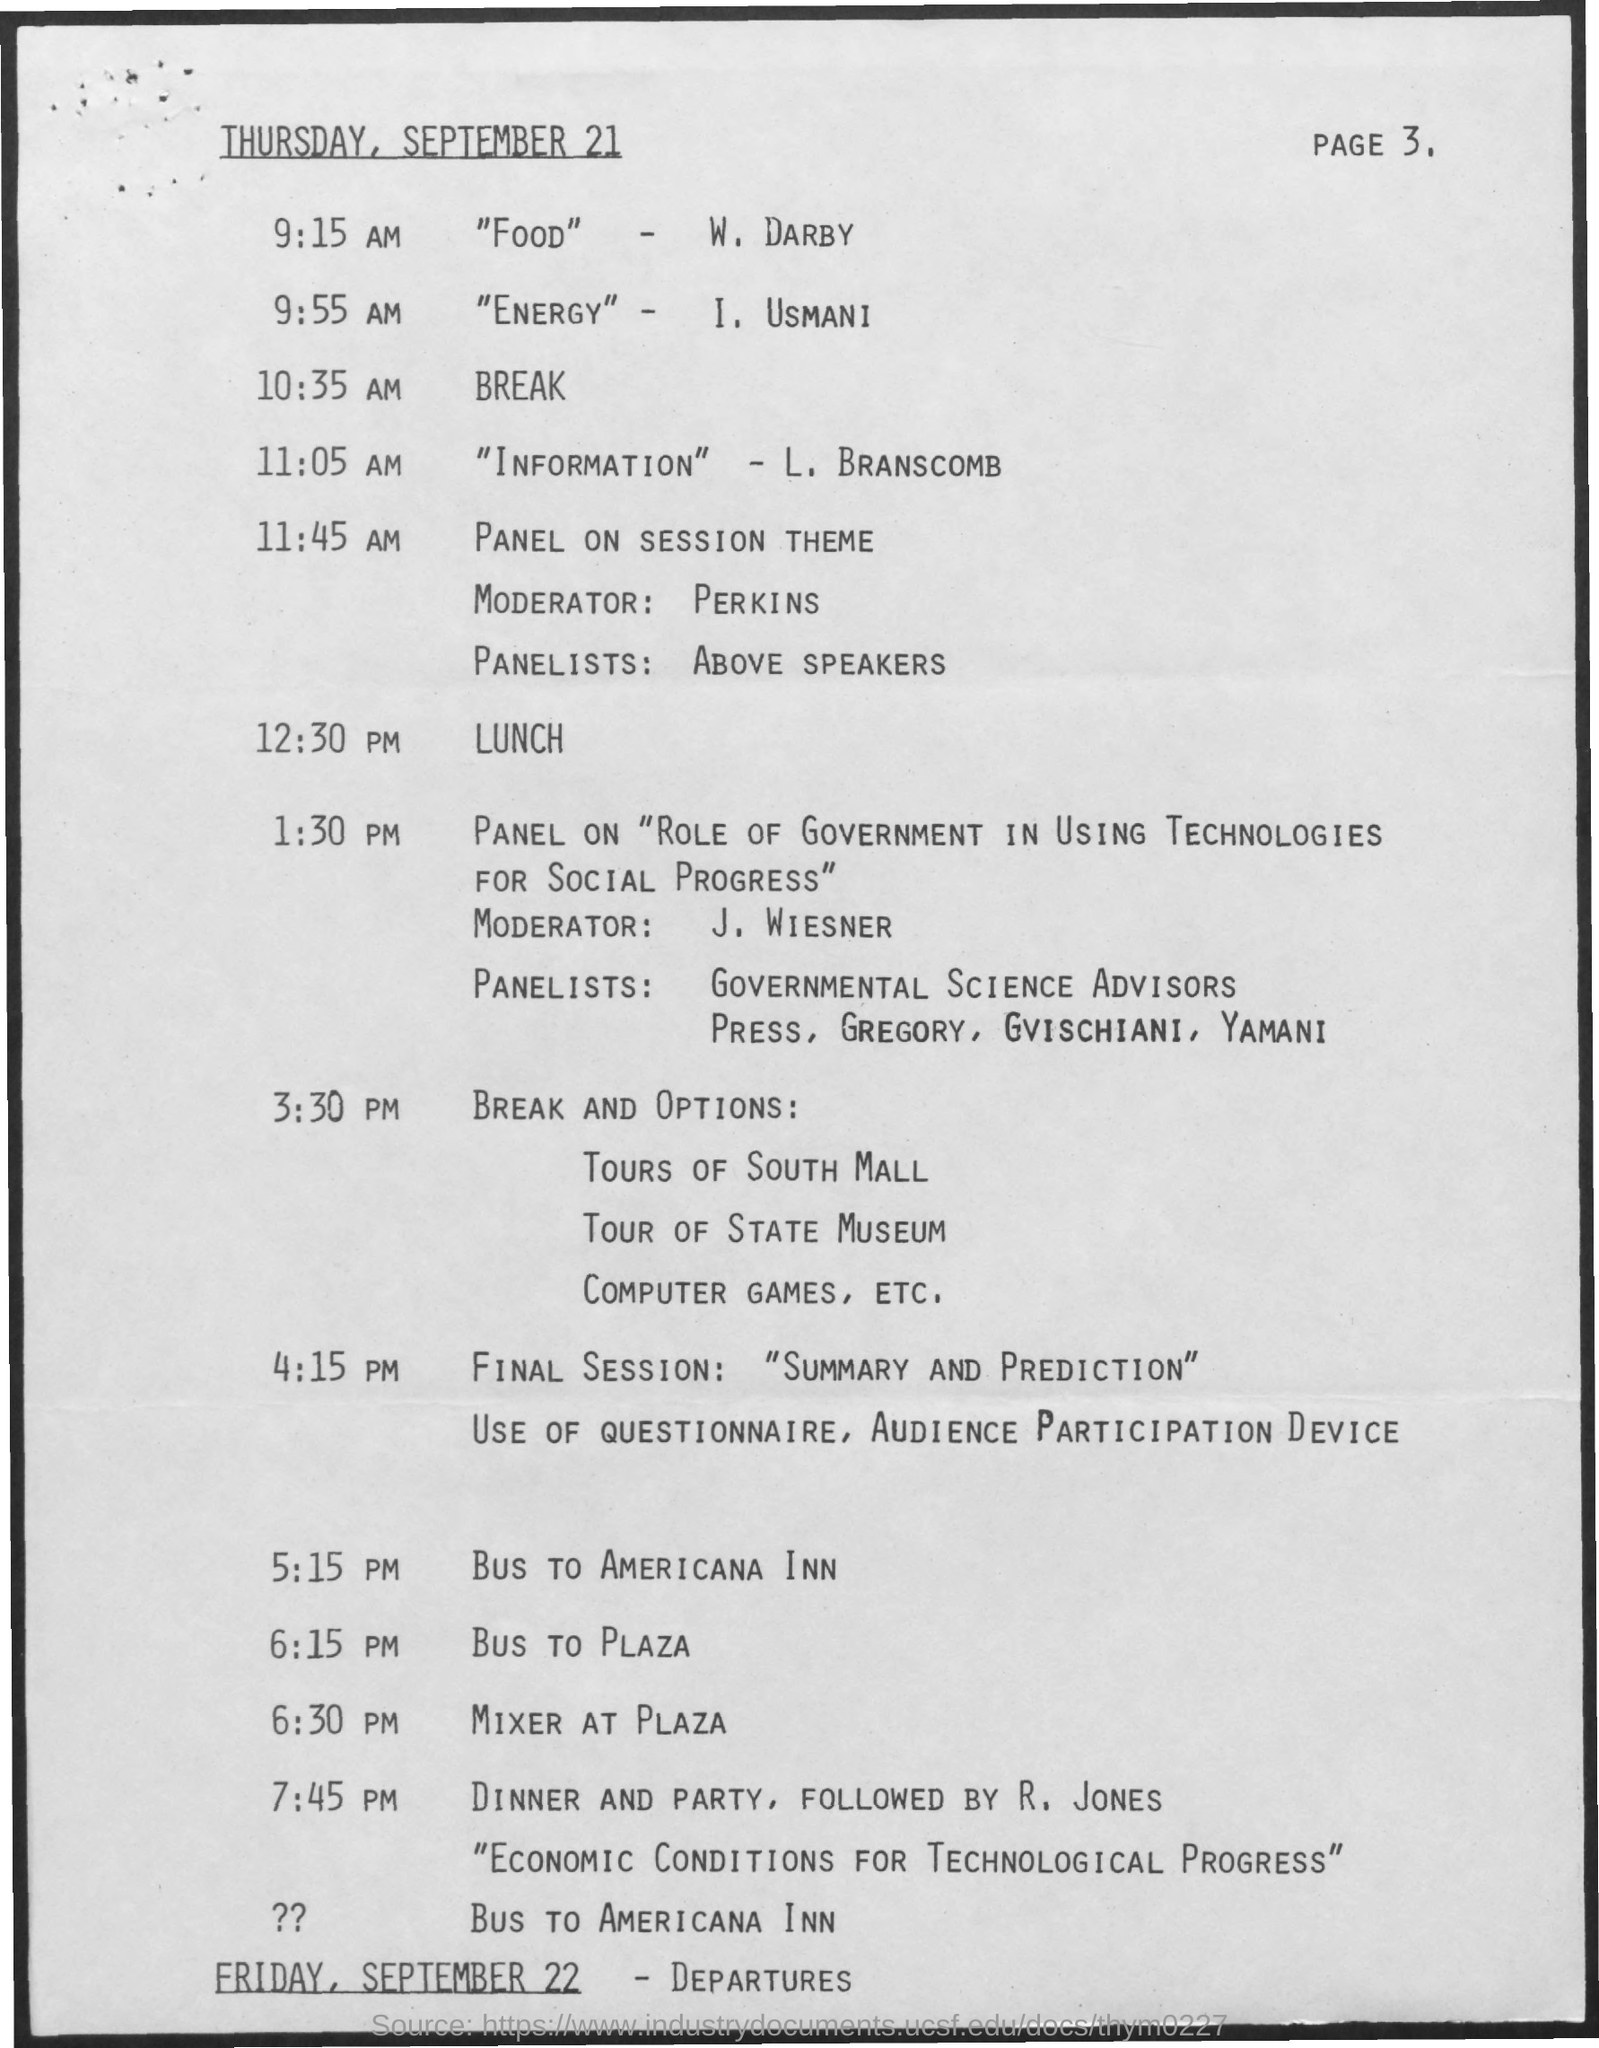When is the "Food" talk by W. Draby on Thursday, September 21?
Your answer should be compact. 9:15 AM. Who is presenting "Energy"?
Provide a short and direct response. I. Usmani. When is the Break on Thursday, September 21?
Offer a terse response. 10:35 AM. Who is presenting "Information"?
Provide a succinct answer. L. Branscomb. When is the "Information" talk by L. Branscomb on Thursday, September 21?
Your response must be concise. 11:05 AM. When is the bus to Plaza?
Your answer should be very brief. 6:15 PM. When is the Lunch?
Make the answer very short. 12:30 PM. When are the departures?
Your answer should be compact. Friday, September 22. Who is the moderator for panel on session theme?
Provide a succinct answer. Perkins. 